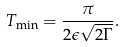Convert formula to latex. <formula><loc_0><loc_0><loc_500><loc_500>T _ { \min } = \frac { \pi } { 2 \epsilon \sqrt { 2 \Gamma } } .</formula> 